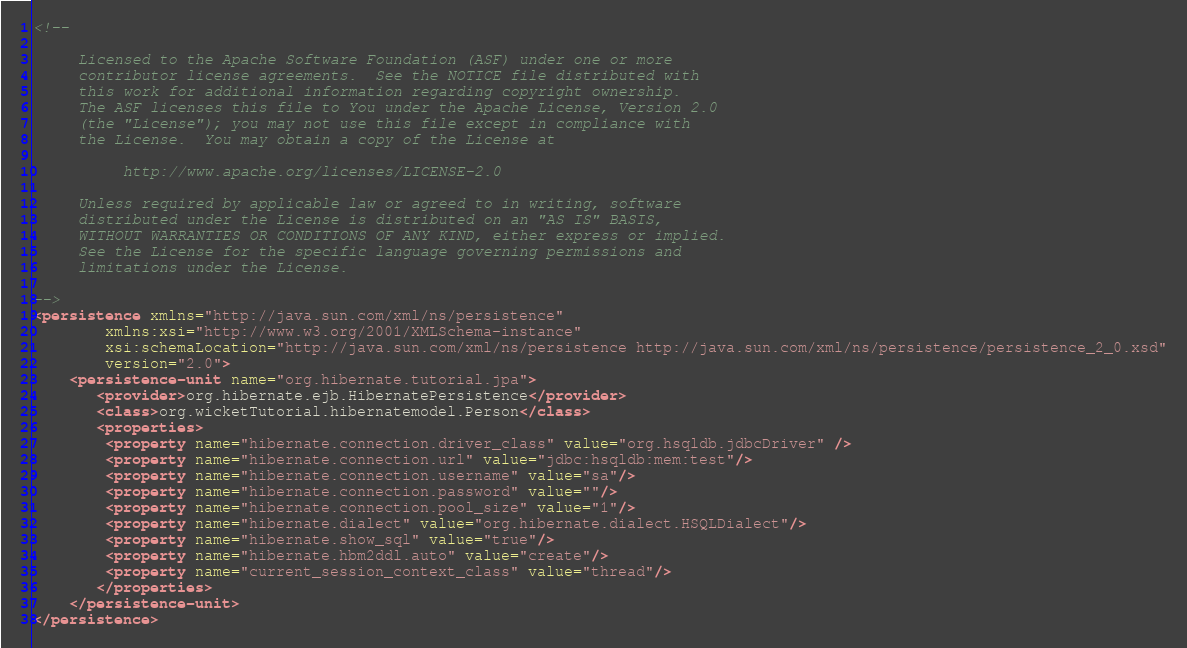Convert code to text. <code><loc_0><loc_0><loc_500><loc_500><_XML_><!--

     Licensed to the Apache Software Foundation (ASF) under one or more
     contributor license agreements.  See the NOTICE file distributed with
     this work for additional information regarding copyright ownership.
     The ASF licenses this file to You under the Apache License, Version 2.0
     (the "License"); you may not use this file except in compliance with
     the License.  You may obtain a copy of the License at

          http://www.apache.org/licenses/LICENSE-2.0

     Unless required by applicable law or agreed to in writing, software
     distributed under the License is distributed on an "AS IS" BASIS,
     WITHOUT WARRANTIES OR CONDITIONS OF ANY KIND, either express or implied.
     See the License for the specific language governing permissions and
     limitations under the License.

-->
<persistence xmlns="http://java.sun.com/xml/ns/persistence"
        xmlns:xsi="http://www.w3.org/2001/XMLSchema-instance"
        xsi:schemaLocation="http://java.sun.com/xml/ns/persistence http://java.sun.com/xml/ns/persistence/persistence_2_0.xsd"
        version="2.0">
    <persistence-unit name="org.hibernate.tutorial.jpa">
       <provider>org.hibernate.ejb.HibernatePersistence</provider>
       <class>org.wicketTutorial.hibernatemodel.Person</class>	
       <properties>
       	<property name="hibernate.connection.driver_class" value="org.hsqldb.jdbcDriver" />
		<property name="hibernate.connection.url" value="jdbc:hsqldb:mem:test"/>
		<property name="hibernate.connection.username" value="sa"/>
		<property name="hibernate.connection.password" value=""/>
		<property name="hibernate.connection.pool_size" value="1"/>
		<property name="hibernate.dialect" value="org.hibernate.dialect.HSQLDialect"/>
		<property name="hibernate.show_sql" value="true"/>
		<property name="hibernate.hbm2ddl.auto" value="create"/>	
		<property name="current_session_context_class" value="thread"/>
       </properties>
    </persistence-unit>
</persistence></code> 